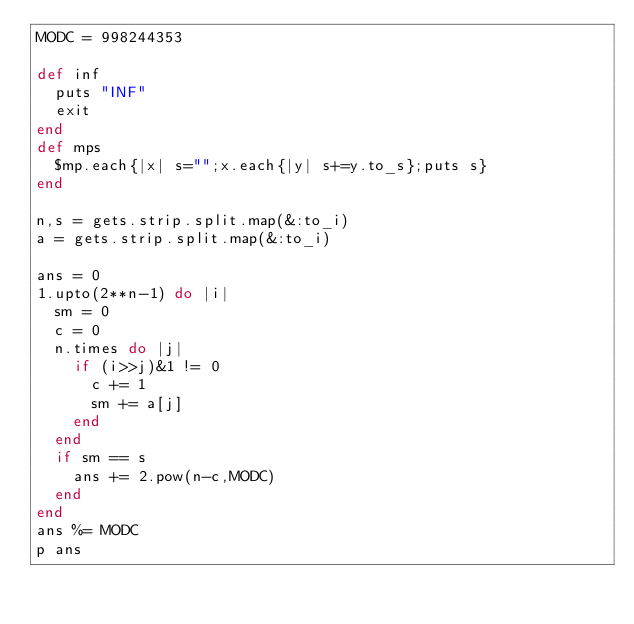<code> <loc_0><loc_0><loc_500><loc_500><_Ruby_>MODC = 998244353

def inf
  puts "INF"
  exit
end
def mps
  $mp.each{|x| s="";x.each{|y| s+=y.to_s};puts s}
end

n,s = gets.strip.split.map(&:to_i)
a = gets.strip.split.map(&:to_i)

ans = 0
1.upto(2**n-1) do |i|
  sm = 0
  c = 0
  n.times do |j|
    if (i>>j)&1 != 0
      c += 1
      sm += a[j]
    end
  end
  if sm == s
    ans += 2.pow(n-c,MODC)
  end
end
ans %= MODC
p ans</code> 